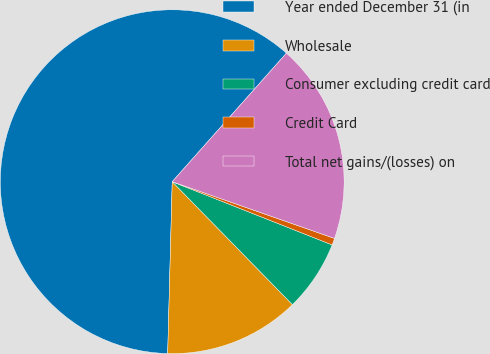Convert chart to OTSL. <chart><loc_0><loc_0><loc_500><loc_500><pie_chart><fcel>Year ended December 31 (in<fcel>Wholesale<fcel>Consumer excluding credit card<fcel>Credit Card<fcel>Total net gains/(losses) on<nl><fcel>61.14%<fcel>12.74%<fcel>6.69%<fcel>0.64%<fcel>18.79%<nl></chart> 